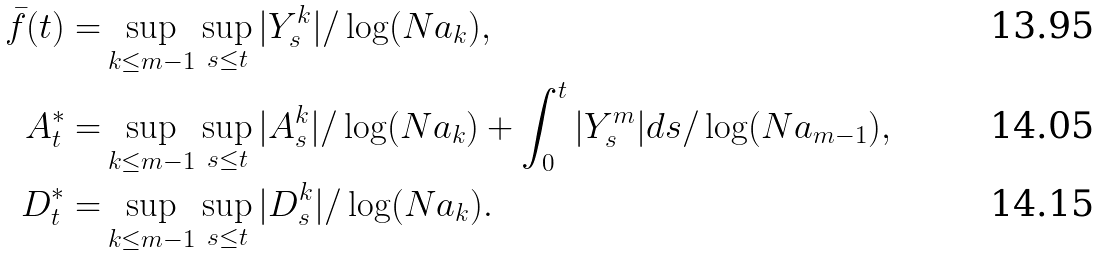Convert formula to latex. <formula><loc_0><loc_0><loc_500><loc_500>\bar { f } ( t ) = & \sup _ { k \leq m - 1 } \sup _ { s \leq t } | Y _ { s } ^ { k } | / \log ( N a _ { k } ) , \\ A ^ { * } _ { t } = & \sup _ { k \leq m - 1 } \sup _ { s \leq t } | A ^ { k } _ { s } | / \log ( N a _ { k } ) + \int _ { 0 } ^ { t } | Y _ { s } ^ { m } | d s / \log ( N a _ { m - 1 } ) , \\ D ^ { * } _ { t } = & \sup _ { k \leq m - 1 } \sup _ { s \leq t } | D _ { s } ^ { k } | / \log ( N a _ { k } ) .</formula> 